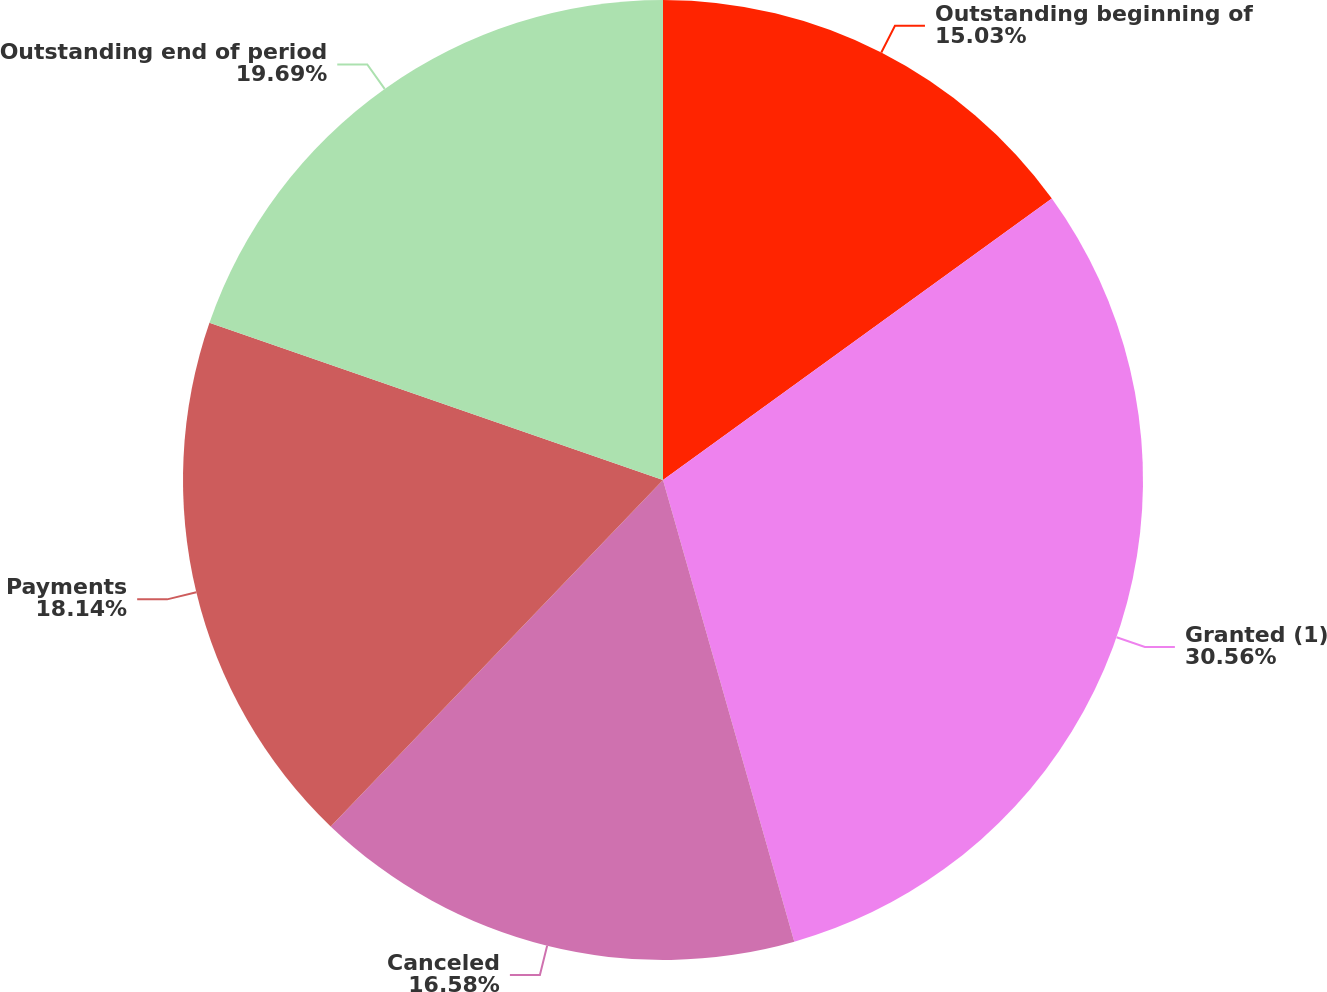<chart> <loc_0><loc_0><loc_500><loc_500><pie_chart><fcel>Outstanding beginning of<fcel>Granted (1)<fcel>Canceled<fcel>Payments<fcel>Outstanding end of period<nl><fcel>15.03%<fcel>30.56%<fcel>16.58%<fcel>18.14%<fcel>19.69%<nl></chart> 